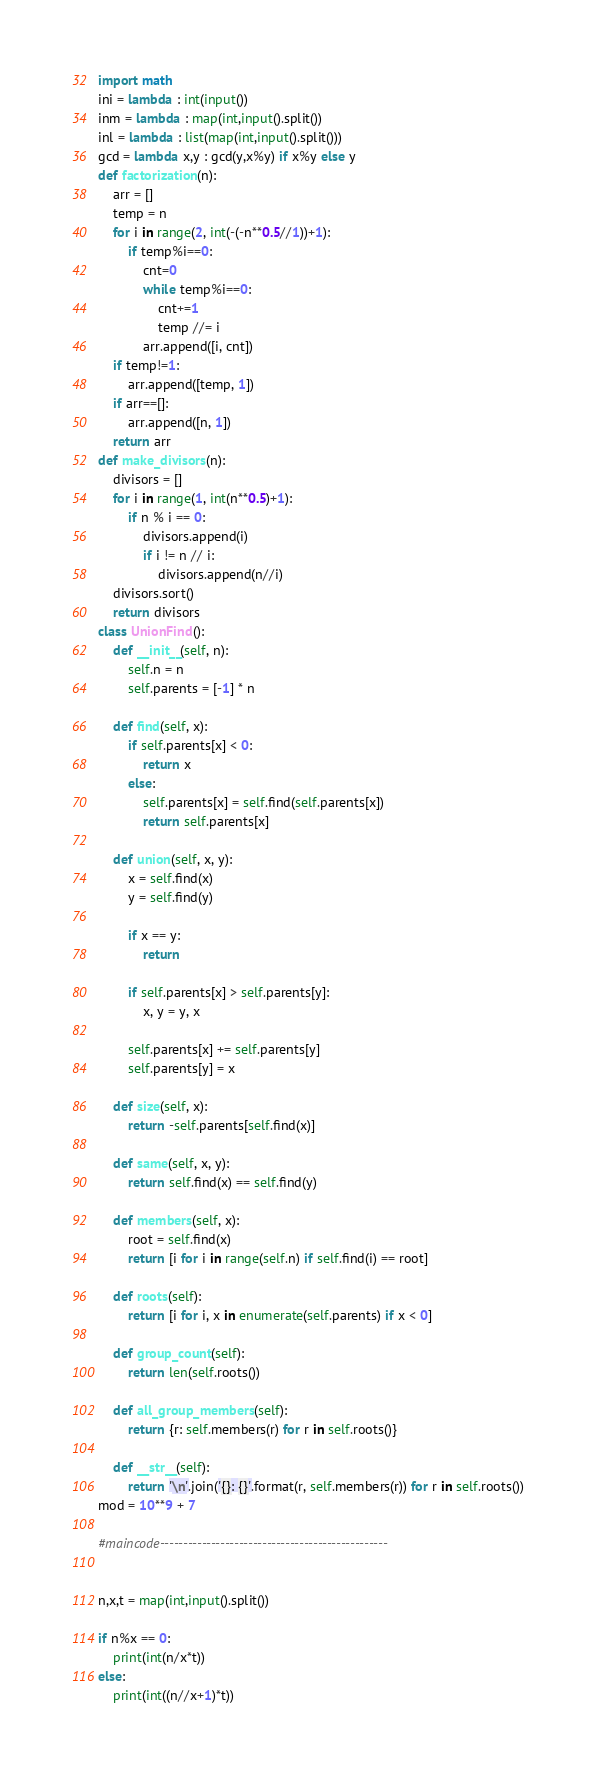<code> <loc_0><loc_0><loc_500><loc_500><_Python_>import math
ini = lambda : int(input())
inm = lambda : map(int,input().split())
inl = lambda : list(map(int,input().split()))
gcd = lambda x,y : gcd(y,x%y) if x%y else y
def factorization(n):
    arr = []
    temp = n
    for i in range(2, int(-(-n**0.5//1))+1):
        if temp%i==0:
            cnt=0
            while temp%i==0:
                cnt+=1
                temp //= i
            arr.append([i, cnt])
    if temp!=1:
        arr.append([temp, 1])
    if arr==[]:
        arr.append([n, 1])
    return arr
def make_divisors(n):
    divisors = []
    for i in range(1, int(n**0.5)+1):
        if n % i == 0:
            divisors.append(i)
            if i != n // i:
                divisors.append(n//i)
    divisors.sort()
    return divisors
class UnionFind():
    def __init__(self, n):
        self.n = n
        self.parents = [-1] * n

    def find(self, x):
        if self.parents[x] < 0:
            return x
        else:
            self.parents[x] = self.find(self.parents[x])
            return self.parents[x]

    def union(self, x, y):
        x = self.find(x)
        y = self.find(y)

        if x == y:
            return

        if self.parents[x] > self.parents[y]:
            x, y = y, x

        self.parents[x] += self.parents[y]
        self.parents[y] = x

    def size(self, x):
        return -self.parents[self.find(x)]

    def same(self, x, y):
        return self.find(x) == self.find(y)

    def members(self, x):
        root = self.find(x)
        return [i for i in range(self.n) if self.find(i) == root]

    def roots(self):
        return [i for i, x in enumerate(self.parents) if x < 0]

    def group_count(self):
        return len(self.roots())

    def all_group_members(self):
        return {r: self.members(r) for r in self.roots()}

    def __str__(self):
        return '\n'.join('{}: {}'.format(r, self.members(r)) for r in self.roots())
mod = 10**9 + 7

#maincode-------------------------------------------------


n,x,t = map(int,input().split())

if n%x == 0:
    print(int(n/x*t))
else:
    print(int((n//x+1)*t))</code> 